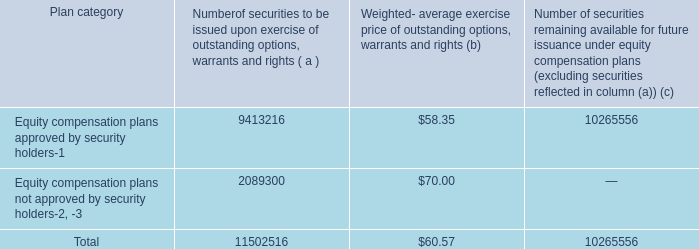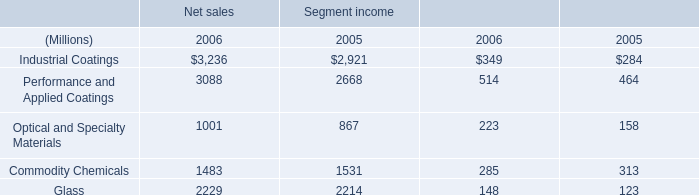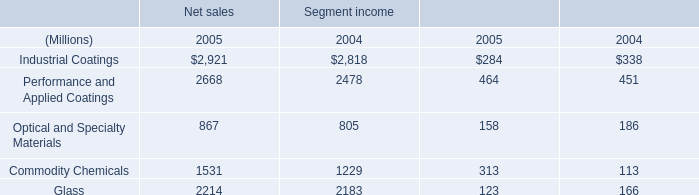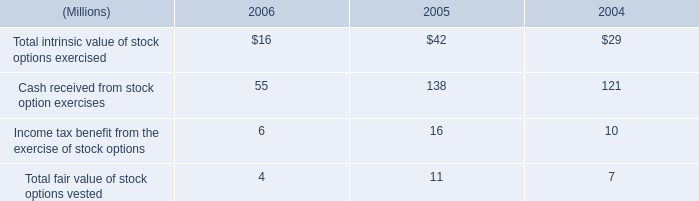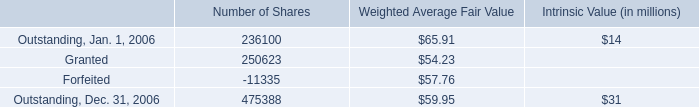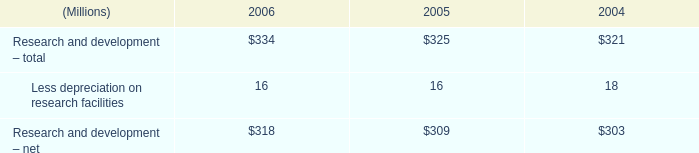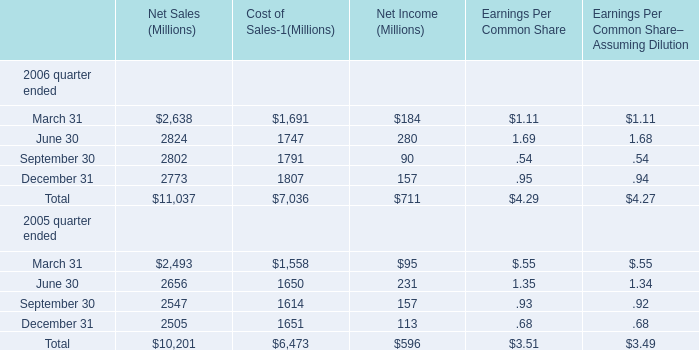In which years is Cost of Sales greater than Net Income (for Total)? 
Answer: 2005 2006. 